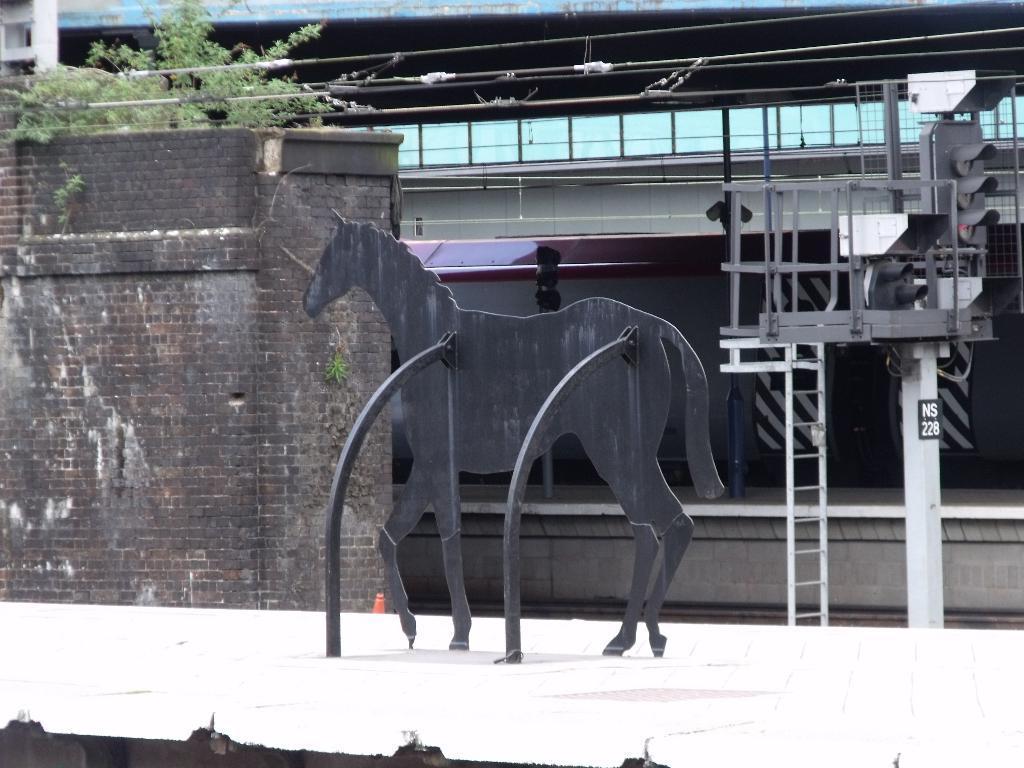In one or two sentences, can you explain what this image depicts? In the image there is an idol of a horse and on the left side there is a brick wall and on that wall there is a plant. In the background there are few traffic signal poles and behind that there are many windows. 